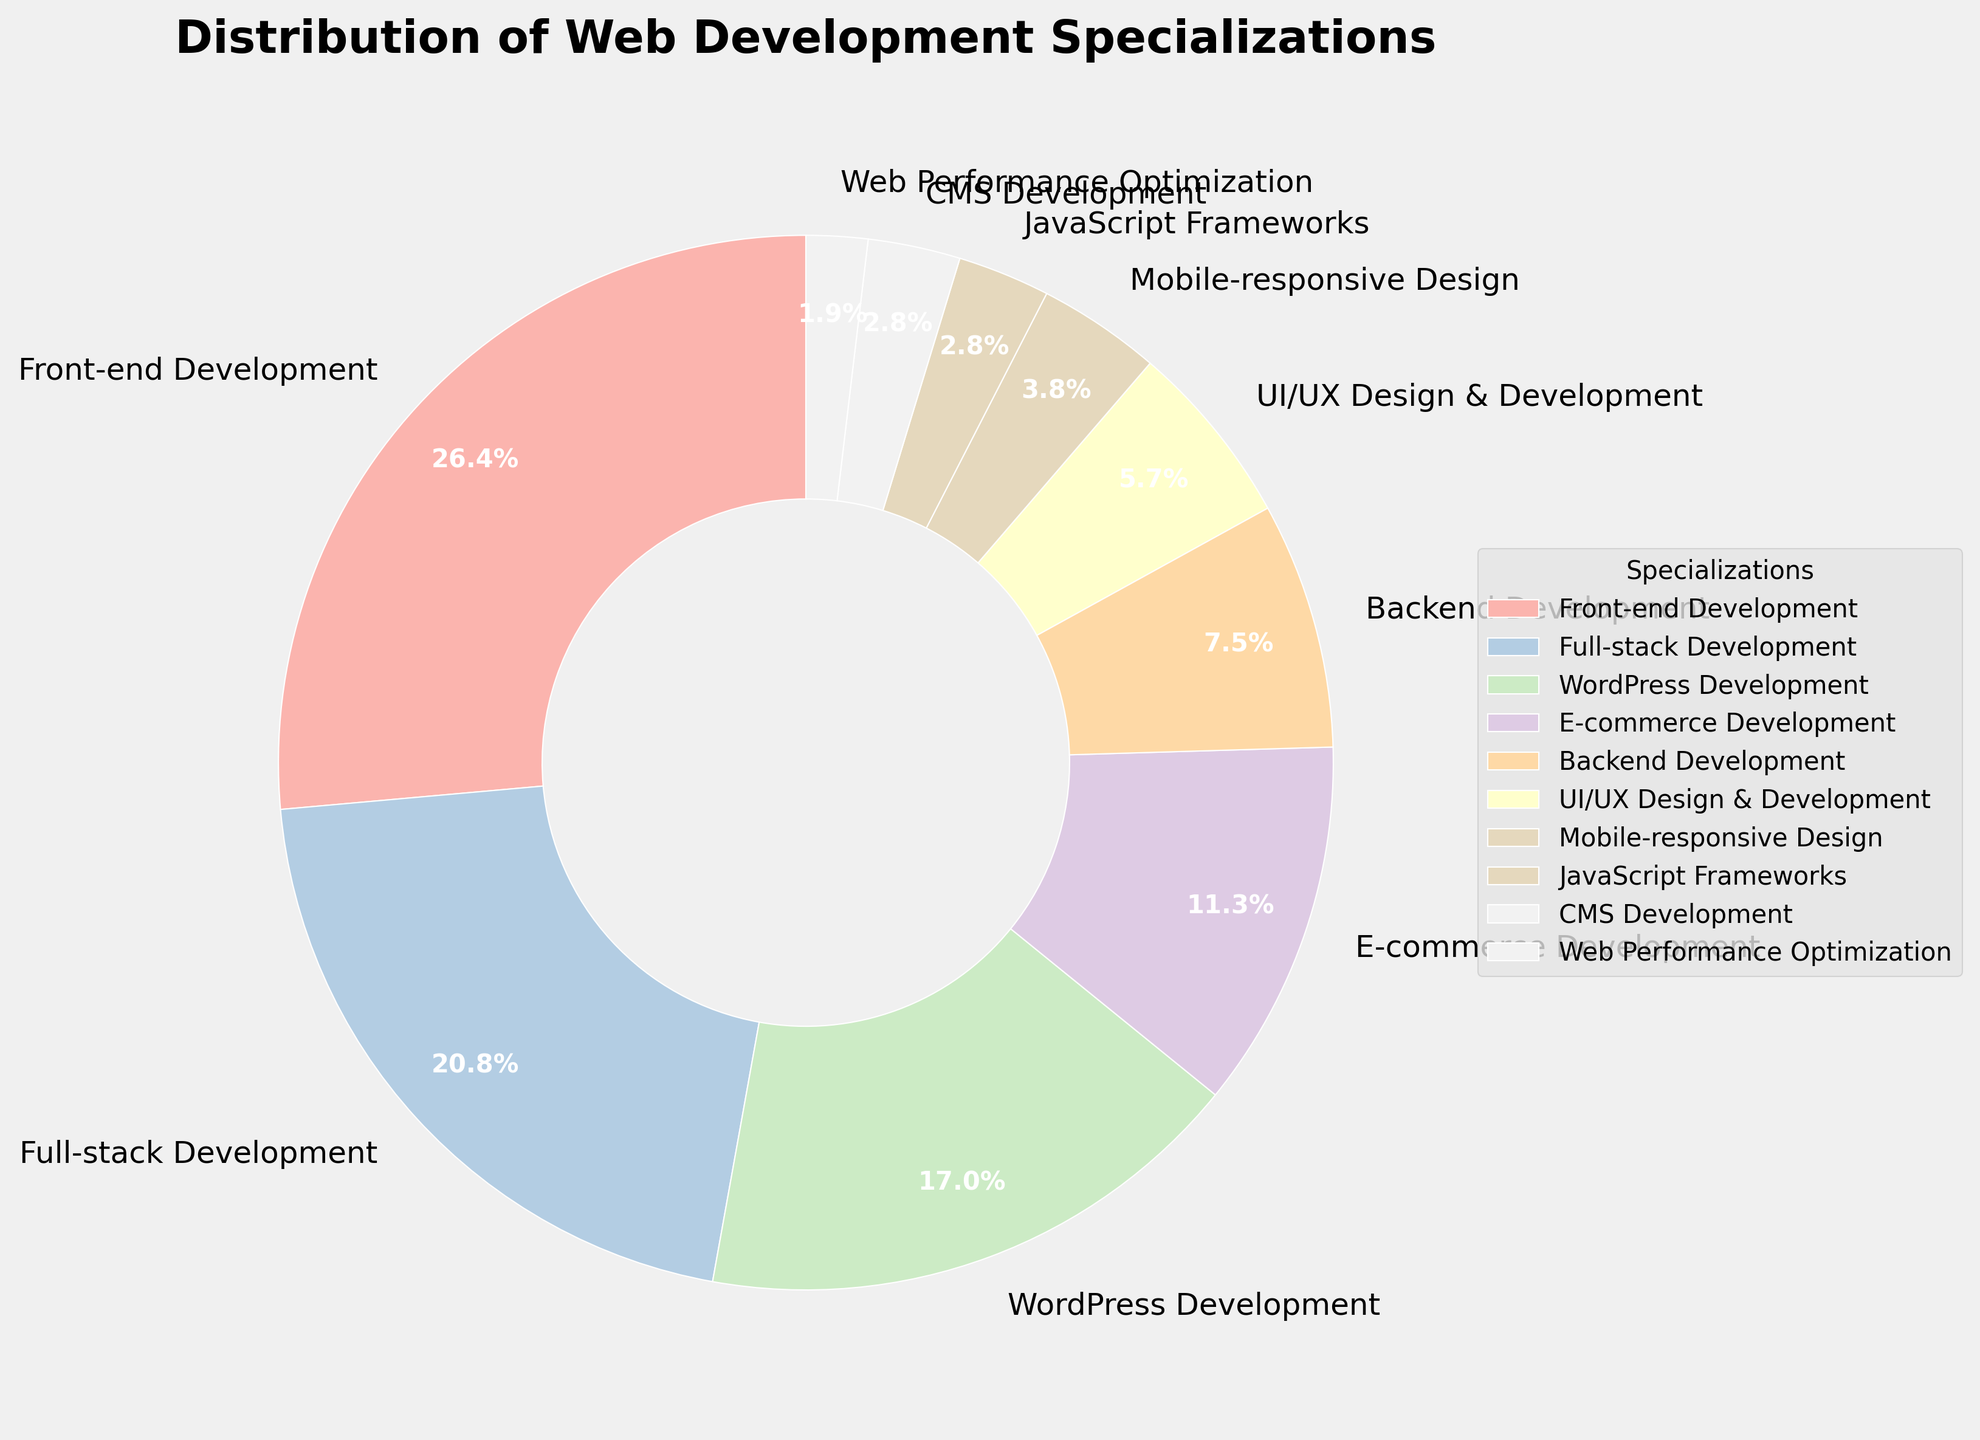Which specialization has the largest percentage? The pie chart shows the percentage distribution, and the largest wedge corresponds to Front-end Development with 28%.
Answer: Front-end Development Which specialization has the smallest percentage? Observing the wedges' sizes in the pie chart, Web Performance Optimization has the smallest segment at 2%.
Answer: Web Performance Optimization How much more is the percentage of Full-stack Development compared to Backend Development? Full-stack Development is 22% and Backend Development is 8%. Subtract the two percentages to find the difference: 22% - 8% = 14%.
Answer: 14% What is the combined percentage of WordPress Development and E-commerce Development? Sum the percentages of WordPress Development (18%) and E-commerce Development (12%): 18% + 12% = 30%.
Answer: 30% Which specialization has approximately half the percentage of Front-end Development? Front-end Development is 28%. Half of 28% is 14%. E-commerce Development closely fits this with 12%, but it is the closest to 14%.
Answer: E-commerce Development What is the sum of percentages of all specializations less than 5%? Add the percentages of Mobile-responsive Design (4%), JavaScript Frameworks (3%), CMS Development (3%), and Web Performance Optimization (2%): 4% + 3% + 3% + 2% = 12%.
Answer: 12% Which specializations together make up more than half of the total percentage? Front-end Development (28%), Full-stack Development (22%), and WordPress Development (18%) together comprise more than 50%: 28% + 22% + 18% = 68%.
Answer: Front-end Development, Full-stack Development, WordPress Development What percentage of specializations are related to design? Combine the percentages of UI/UX Design & Development (6%) and Mobile-responsive Design (4%): 6% + 4% = 10%.
Answer: 10% If you combine Full-stack Development and Backend Development, what is their combined percentage? Sum the percentages of Full-stack Development (22%) and Backend Development (8%): 22% + 8% = 30%.
Answer: 30% How does the combined percentage of CMS Development and Web Performance Optimization compare to that of JavaScript Frameworks? Sum the percentages of CMS Development (3%) and Web Performance Optimization (2%): 3% + 2% = 5%, which is greater than JavaScript Frameworks (3%).
Answer: 5% (greater than 3%) 